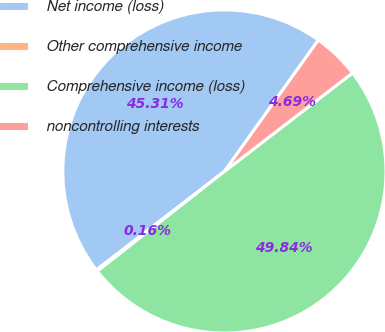<chart> <loc_0><loc_0><loc_500><loc_500><pie_chart><fcel>Net income (loss)<fcel>Other comprehensive income<fcel>Comprehensive income (loss)<fcel>noncontrolling interests<nl><fcel>45.31%<fcel>0.16%<fcel>49.84%<fcel>4.69%<nl></chart> 